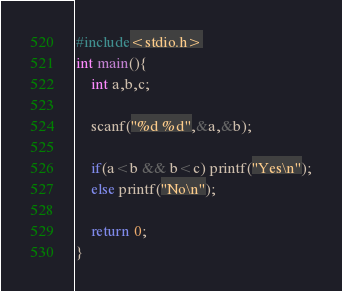Convert code to text. <code><loc_0><loc_0><loc_500><loc_500><_C_>#include<stdio.h>
int main(){
	int a,b,c;
	
	scanf("%d %d",&a,&b);
	
	if(a<b && b<c) printf("Yes\n");
	else printf("No\n");

	return 0;
}</code> 